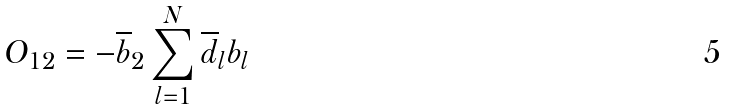Convert formula to latex. <formula><loc_0><loc_0><loc_500><loc_500>O _ { 1 2 } = - \overline { b } _ { 2 } \sum _ { l = 1 } ^ { N } \overline { d } _ { l } b _ { l }</formula> 